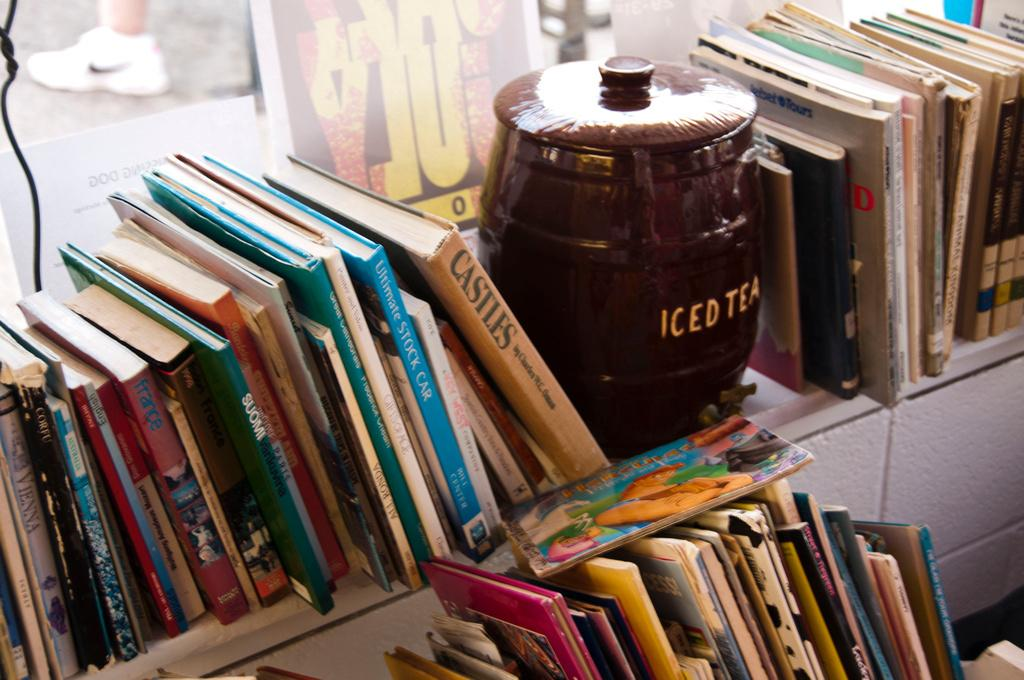<image>
Describe the image concisely. Books on a shelf with an Iced Tea pot, one of the books says Castles. 